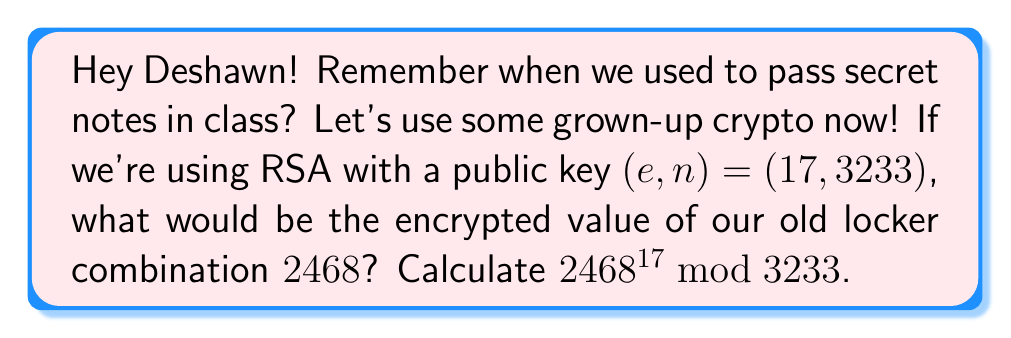Could you help me with this problem? Let's approach this step-by-step using the modular exponentiation algorithm:

1) We need to calculate $2468^{17} \bmod 3233$.

2) First, let's convert the exponent 17 to binary: $17 = 10001_2$

3) Now, we'll use the square-and-multiply method:

   $2468^1 \bmod 3233 = 2468$
   
   $2468^2 \bmod 3233 = 2468^2 \bmod 3233 = 1652$
   
   $1652^2 \bmod 3233 = 102$
   
   $102^2 \bmod 3233 = 10404 \bmod 3233 = 2705$
   
   $2705^2 \bmod 3233 = 2822$

4) Now, we multiply the results for each '1' bit in the binary exponent:

   $2468 \cdot 2822 \bmod 3233 = 2805$

Therefore, $2468^{17} \bmod 3233 = 2805$.
Answer: 2805 